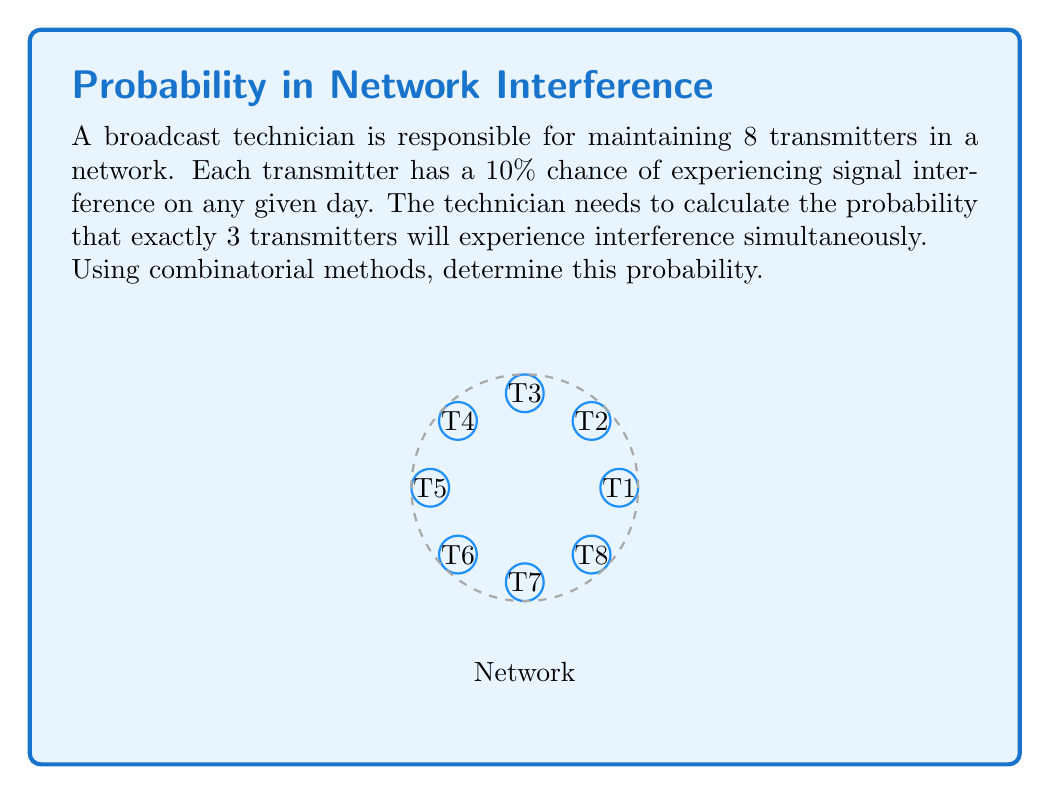Provide a solution to this math problem. To solve this problem, we'll use the binomial probability formula:

$$P(X = k) = \binom{n}{k} p^k (1-p)^{n-k}$$

Where:
- $n$ is the total number of transmitters (8)
- $k$ is the number of transmitters we want to experience interference (3)
- $p$ is the probability of interference for each transmitter (10% or 0.1)

Step 1: Calculate the combination $\binom{8}{3}$
$$\binom{8}{3} = \frac{8!}{3!(8-3)!} = \frac{8!}{3!5!} = 56$$

Step 2: Calculate $p^k$
$$0.1^3 = 0.001$$

Step 3: Calculate $(1-p)^{n-k}$
$$(1-0.1)^{8-3} = 0.9^5 \approx 0.59049$$

Step 4: Multiply all components
$$56 \times 0.001 \times 0.59049 \approx 0.033067$$

Therefore, the probability of exactly 3 transmitters experiencing interference simultaneously is approximately 0.033067 or 3.3067%.
Answer: $0.033067$ or $3.3067\%$ 